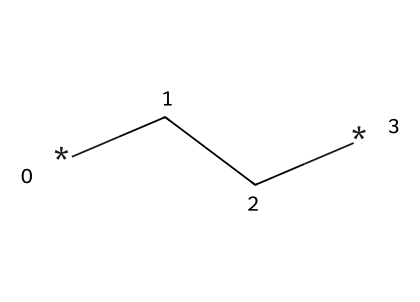What is the molecular formula of the compound represented by the SMILES? The SMILES <SMILES>*CC*</SMILES> indicates that there are two carbon atoms (C) and six hydrogen atoms (H) connected as a straight chain, which can be deduced from the notation. This gives us a molecular formula of C2H6.
Answer: C2H6 How many chiral centers are present in this compound? A chiral center typically requires a carbon atom to be bonded to four different substituents. In the case of the SMILES provided, both carbon atoms are bonded to hydrogen atoms and other carbon atoms but do not fulfill the requirement for unique substituents. Therefore, there are no chiral centers.
Answer: 0 What type of compound is represented by this SMILES? Analyzing the SMILES shows it is an alkane due to the single bonds between carbons (and saturated nature), which classifies it under hydrocarbons without functional groups.
Answer: alkane How many total hydrogen atoms are there in this compound? The structure indicated by the two carbon atoms suggests that each carbon contributes enough bonds to satisfy the tetravalent nature of carbon, resulting in a total of six hydrogen atoms attached to the carbon atoms.
Answer: 6 Is this compound optically active? Since this compound does not possess any chiral centers, it cannot rotate plane-polarized light, making it optically inactive.
Answer: no What kind of bonds exist within the compound (single, double, triple)? The SMILES structure shows only single bonds connecting the carbon atoms and their respective hydrogen atoms, categorizing it as a saturated hydrocarbon.
Answer: single What are the potential uses of this compound in artificial turf material? Alkane compounds like the one represented can be strong contributors to the polymer matrix used in synthetic fibers for artificial turf, providing durability and weather resistance.
Answer: synthetic fibers 